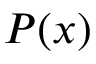<formula> <loc_0><loc_0><loc_500><loc_500>P ( x )</formula> 